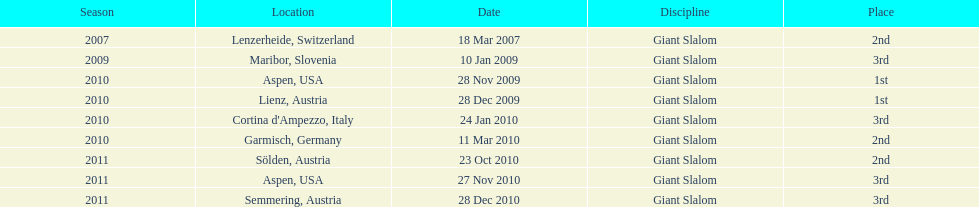What is the total number of her 2nd place finishes on the list? 3. 